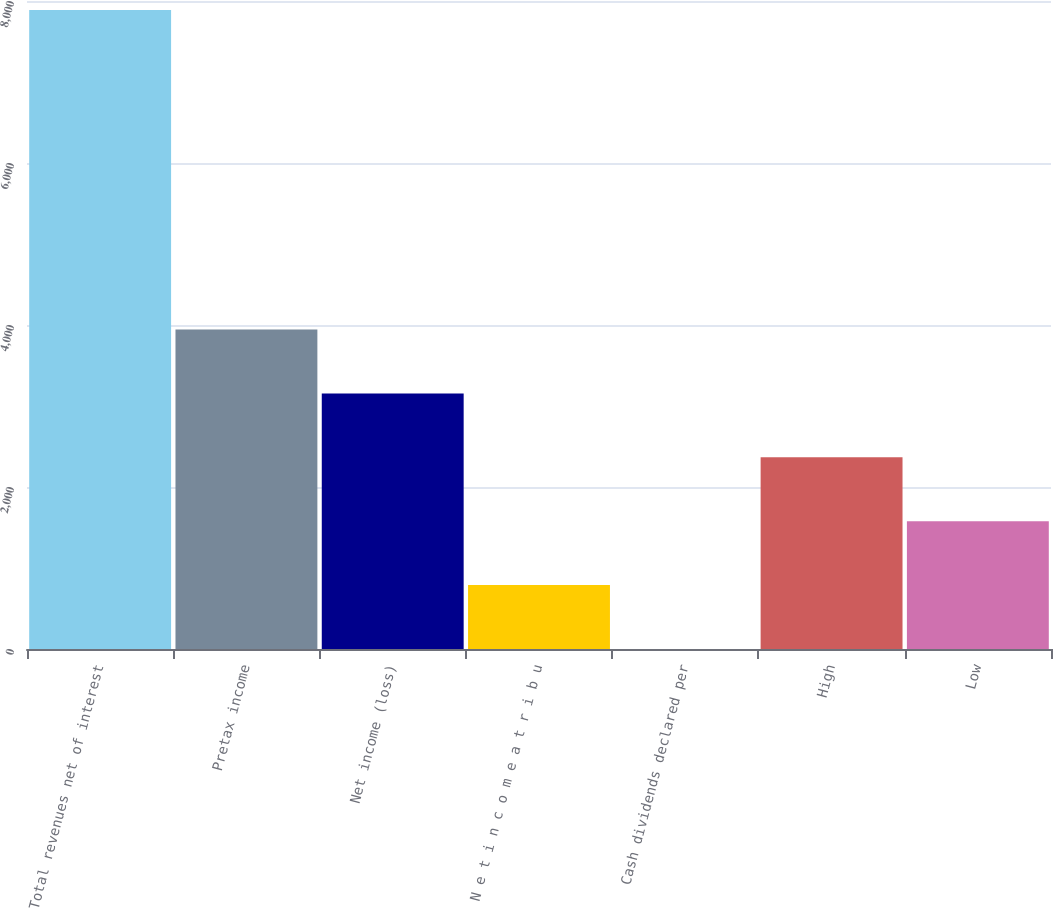<chart> <loc_0><loc_0><loc_500><loc_500><bar_chart><fcel>Total revenues net of interest<fcel>Pretax income<fcel>Net income (loss)<fcel>N e t i n c o m e a t r i b u<fcel>Cash dividends declared per<fcel>High<fcel>Low<nl><fcel>7889<fcel>3944.67<fcel>3155.8<fcel>789.19<fcel>0.32<fcel>2366.93<fcel>1578.06<nl></chart> 